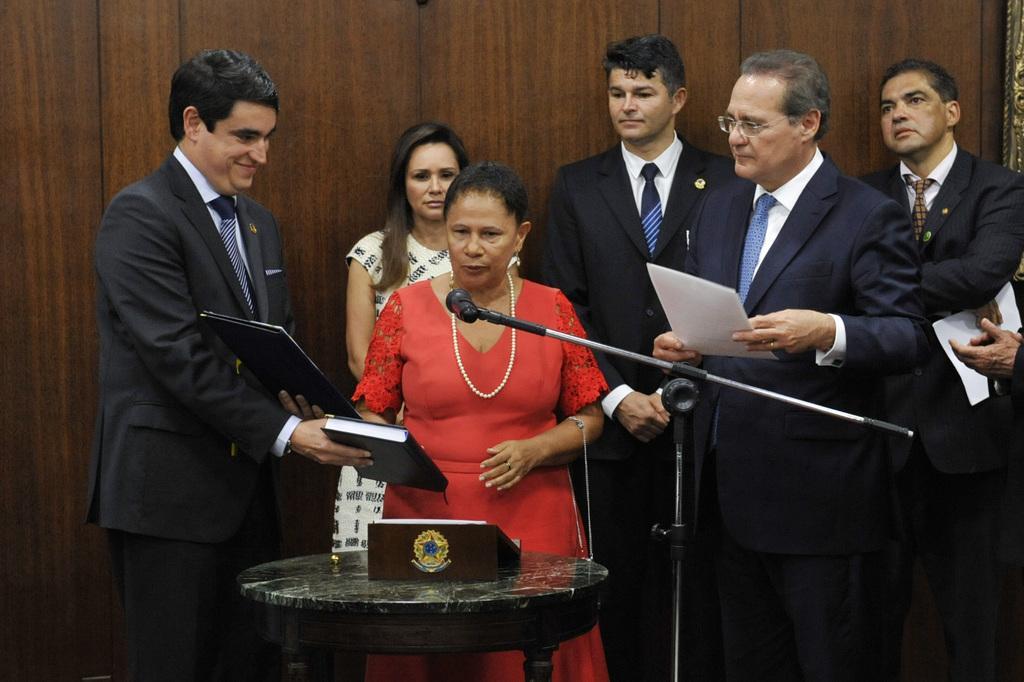Can you describe this image briefly? In the foreground of this image, there is a table and a book stand like an object on it. There is a woman standing behind it is talking into the mic which is attached to the stand. There is a man wearing suit standing beside her holding books and having smile on his face. In the background, there are persons standing and holding papers and a wooden wall. 